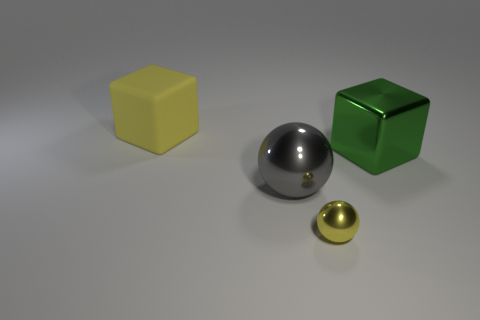Are there any other things that are the same material as the yellow block?
Offer a very short reply. No. There is a green object that is the same size as the yellow rubber thing; what shape is it?
Offer a very short reply. Cube. Are there any green shiny things in front of the yellow ball?
Give a very brief answer. No. Are there any objects in front of the large block behind the metal block?
Offer a very short reply. Yes. Is the number of big green blocks that are in front of the large green shiny block less than the number of yellow metal spheres in front of the tiny ball?
Offer a terse response. No. Is there any other thing that is the same size as the rubber object?
Offer a very short reply. Yes. There is a small yellow thing; what shape is it?
Offer a terse response. Sphere. What is the yellow object behind the small yellow ball made of?
Offer a terse response. Rubber. There is a yellow object that is to the right of the yellow thing that is behind the cube that is right of the rubber cube; what is its size?
Make the answer very short. Small. Does the yellow thing on the right side of the rubber cube have the same material as the big block on the right side of the yellow shiny ball?
Offer a terse response. Yes. 